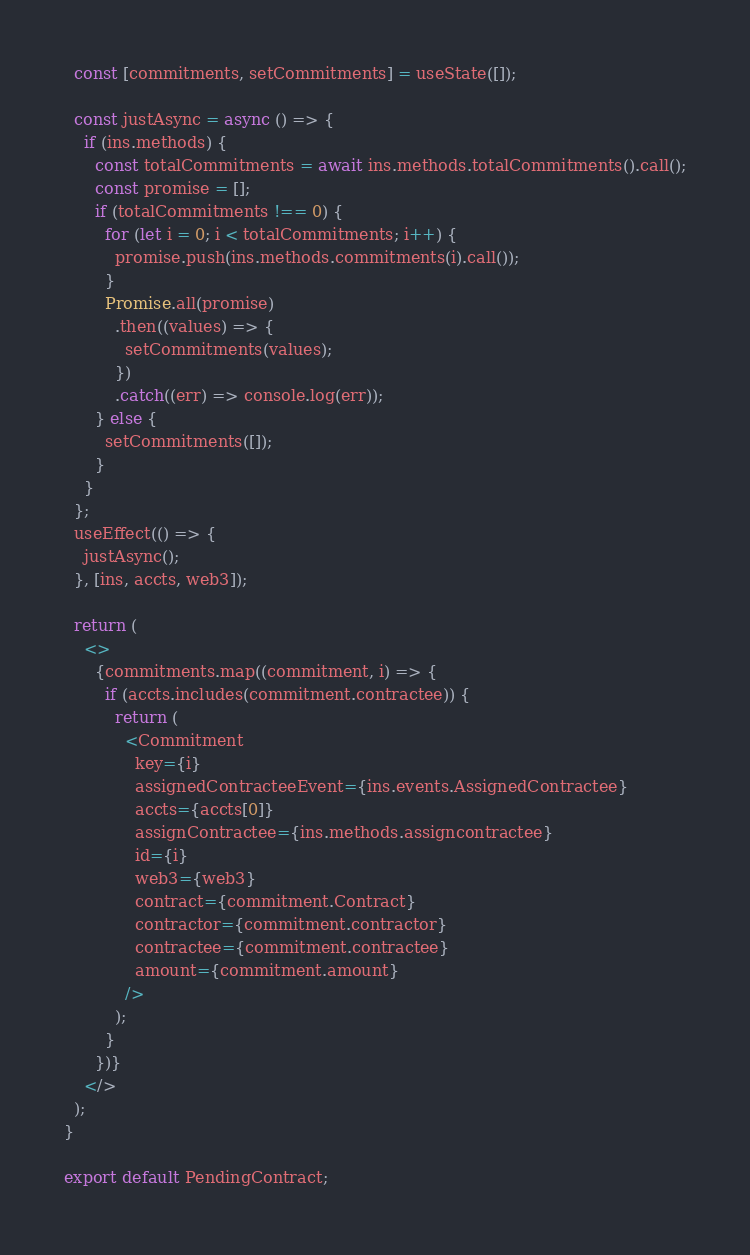<code> <loc_0><loc_0><loc_500><loc_500><_JavaScript_>  const [commitments, setCommitments] = useState([]);

  const justAsync = async () => {
    if (ins.methods) {
      const totalCommitments = await ins.methods.totalCommitments().call();
      const promise = [];
      if (totalCommitments !== 0) {
        for (let i = 0; i < totalCommitments; i++) {
          promise.push(ins.methods.commitments(i).call());
        }
        Promise.all(promise)
          .then((values) => {
            setCommitments(values);
          })
          .catch((err) => console.log(err));
      } else {
        setCommitments([]);
      }
    }
  };
  useEffect(() => {
    justAsync();
  }, [ins, accts, web3]);

  return (
    <>
      {commitments.map((commitment, i) => {
        if (accts.includes(commitment.contractee)) {
          return (
            <Commitment
              key={i}
              assignedContracteeEvent={ins.events.AssignedContractee}
              accts={accts[0]}
              assignContractee={ins.methods.assigncontractee}
              id={i}
              web3={web3}
              contract={commitment.Contract}
              contractor={commitment.contractor}
              contractee={commitment.contractee}
              amount={commitment.amount}
            />
          );
        }
      })}
    </>
  );
}

export default PendingContract;
</code> 